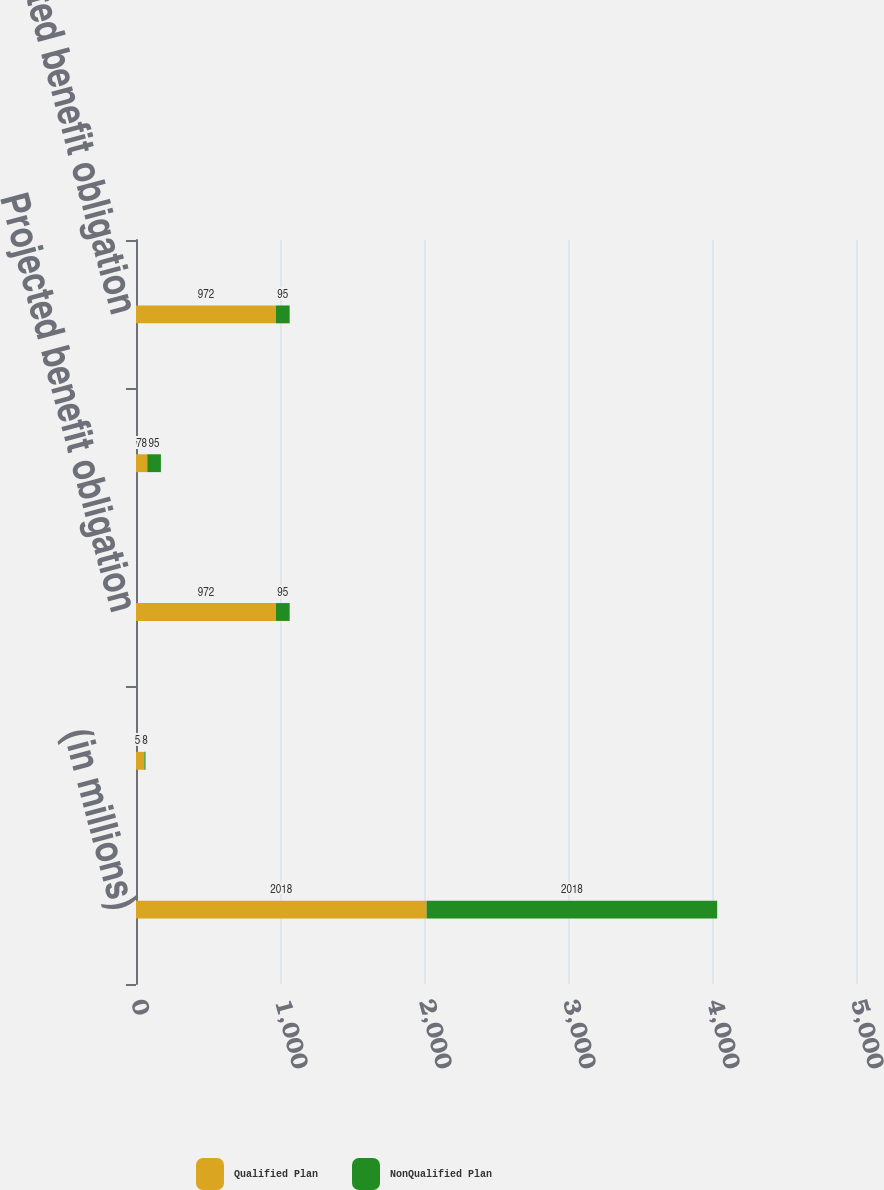<chart> <loc_0><loc_0><loc_500><loc_500><stacked_bar_chart><ecel><fcel>(in millions)<fcel>Benefits and administrative<fcel>Projected benefit obligation<fcel>Pension asset (obligation)<fcel>Accumulated benefit obligation<nl><fcel>Qualified Plan<fcel>2018<fcel>58<fcel>972<fcel>78<fcel>972<nl><fcel>NonQualified Plan<fcel>2018<fcel>8<fcel>95<fcel>95<fcel>95<nl></chart> 